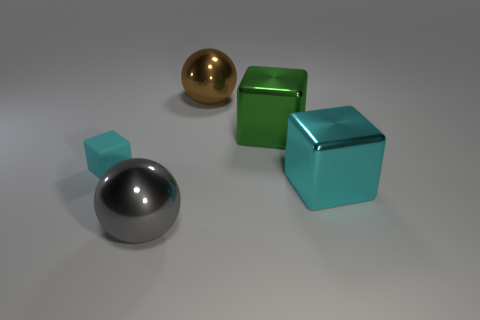Which objects in the image can be classified as cubes? In the image, there are two objects that can be classified as cubes: one large green metal cube and one smaller turquoise cube. 